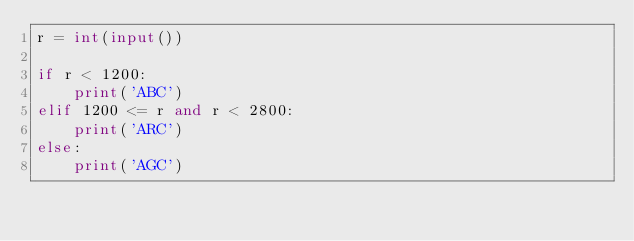<code> <loc_0><loc_0><loc_500><loc_500><_Python_>r = int(input())

if r < 1200:
    print('ABC')
elif 1200 <= r and r < 2800:
    print('ARC')
else:
    print('AGC')</code> 